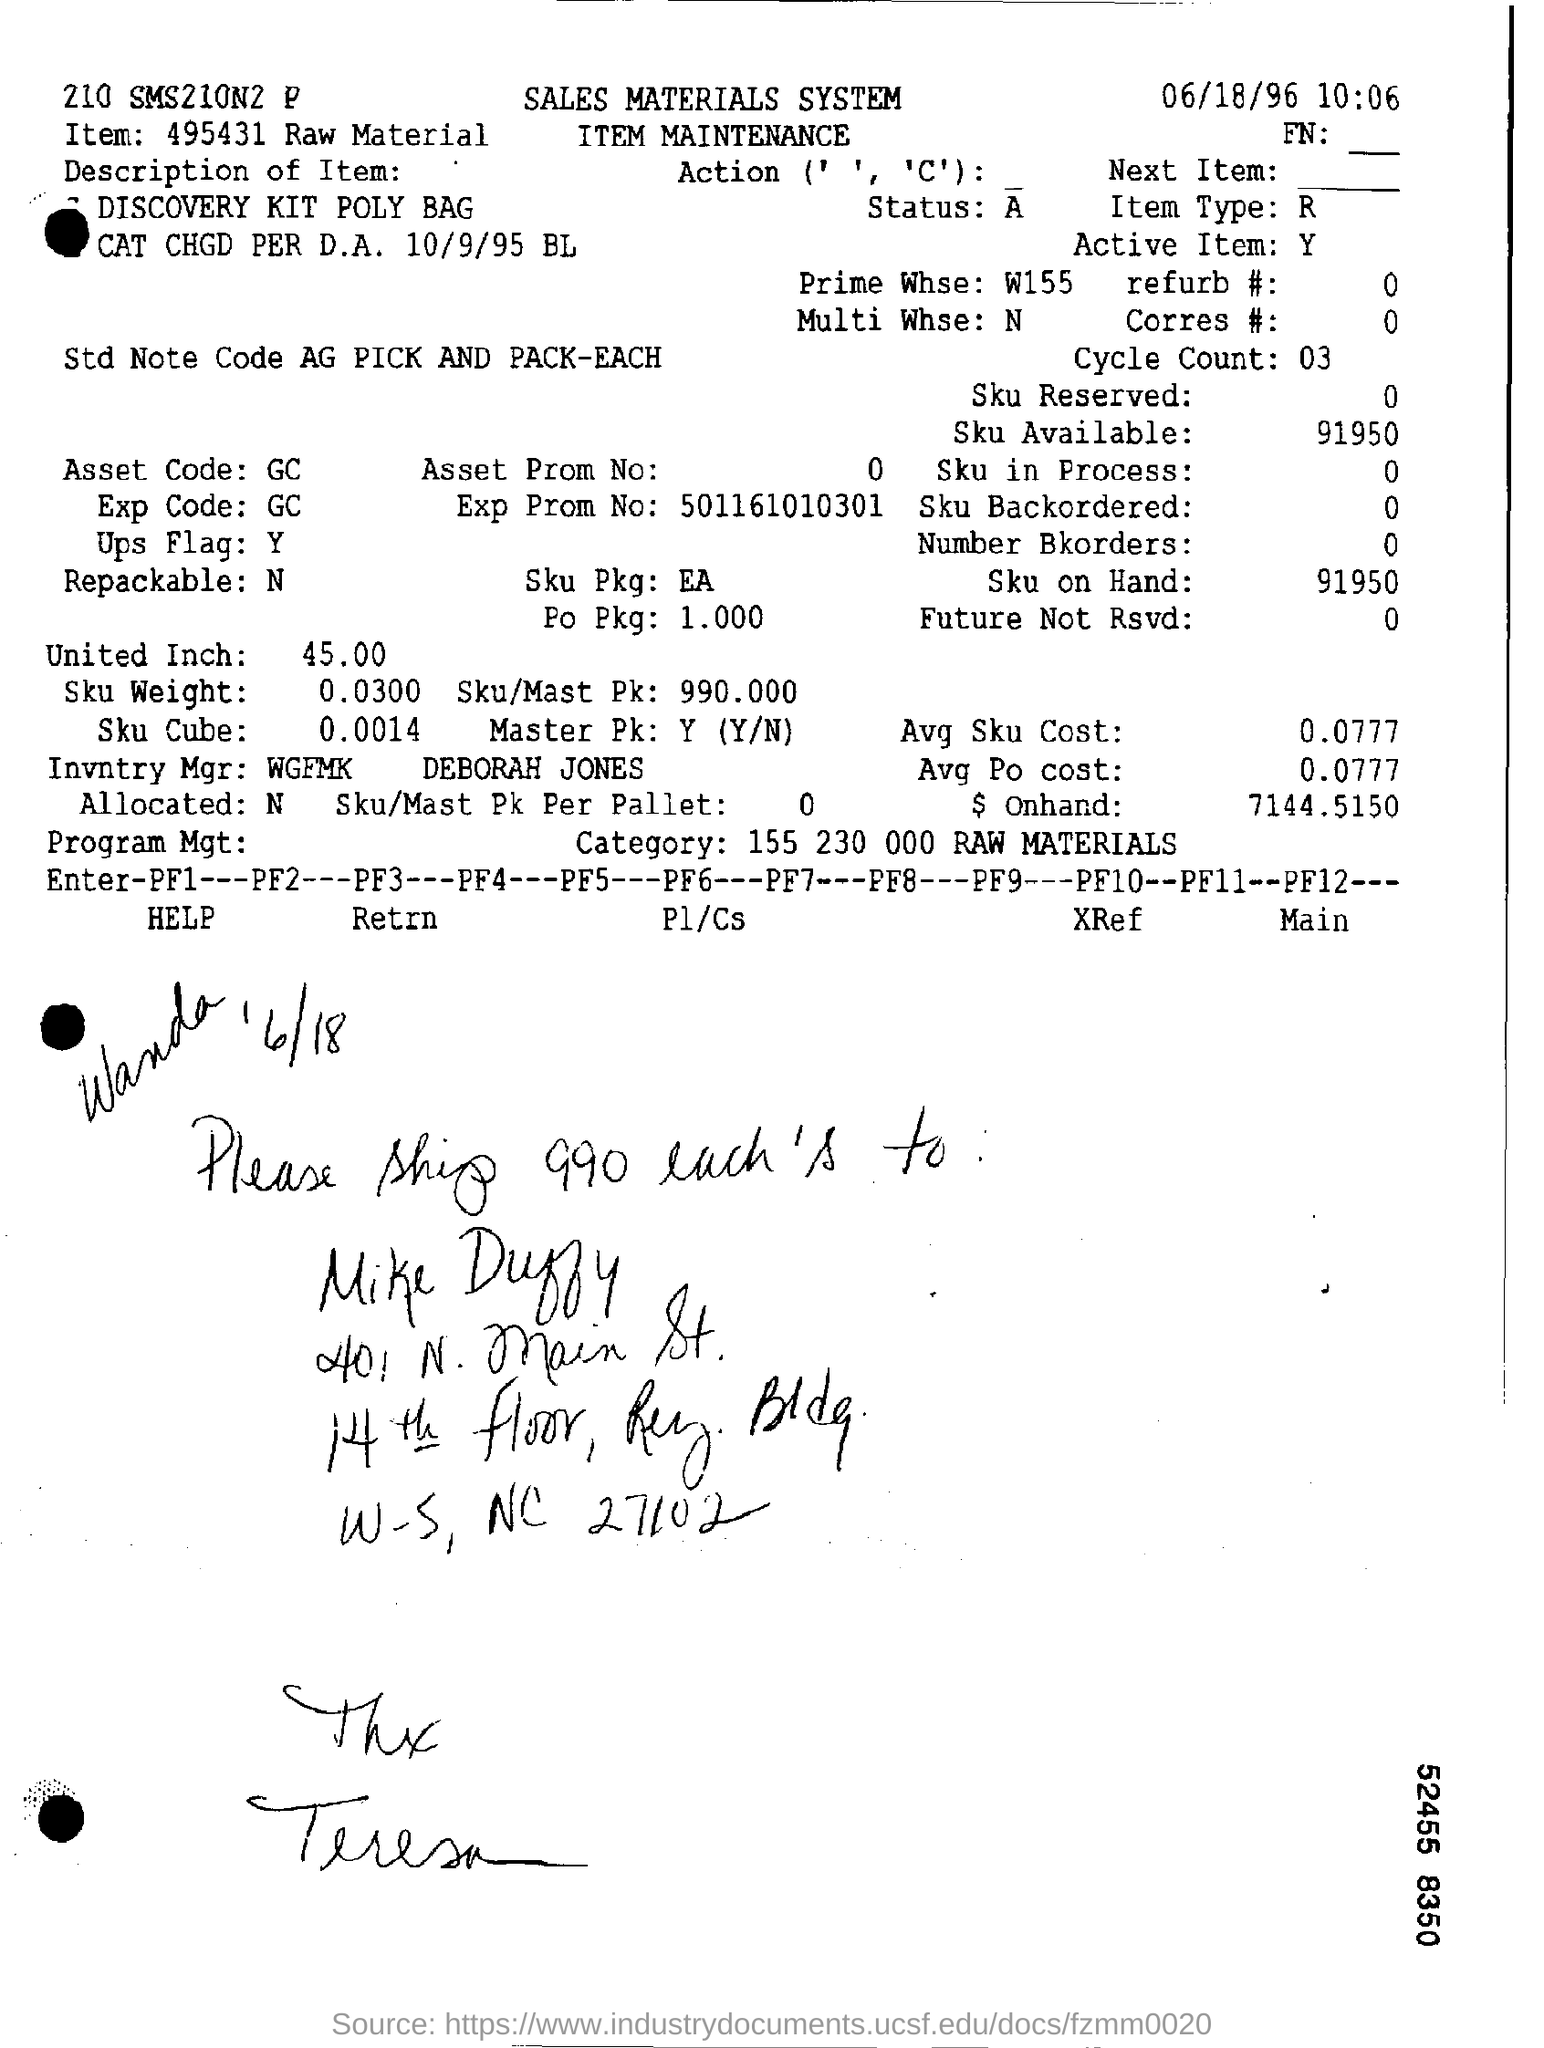What is the asset code mentioned in the document?
Offer a very short reply. GC. What is the Item Type?
Offer a very short reply. R. What is the Prime Whse?
Your answer should be very brief. W155. What is the Sku available?
Keep it short and to the point. 91950. What is the Sku on hand?
Give a very brief answer. 91950. What is the Asset code?
Keep it short and to the point. GC. What is the United Inch?
Give a very brief answer. 45.00. What is the Sku/Mast Pk?
Keep it short and to the point. 990.000. What is the Avg Sku Cost?
Give a very brief answer. 0.0777. What is the $ on hand?
Your answer should be compact. 7144.5150. 